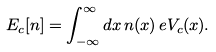<formula> <loc_0><loc_0><loc_500><loc_500>E _ { c } [ n ] = \int _ { - \infty } ^ { \infty } d x \, n ( x ) \, e V _ { c } ( x ) .</formula> 